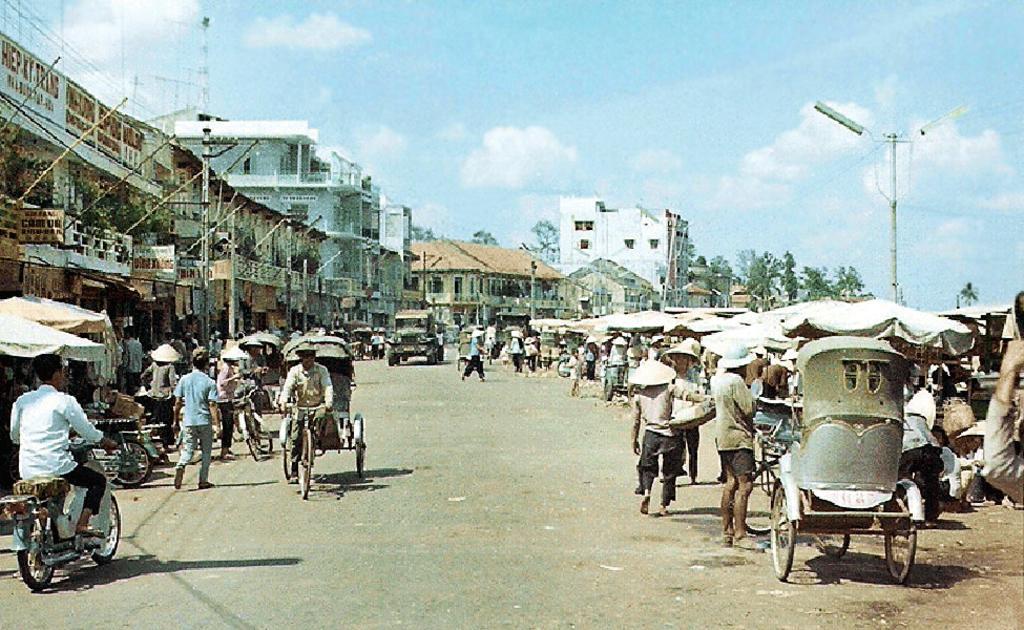In one or two sentences, can you explain what this image depicts? This picture is clicked outside the city. In this picture, we see men are riding the rickshaws and we even see vehicles are moving on the road. On the left side, we see the bikes parked on the road. Beside that, we see white tents, street lights, poles and buildings. On the right side, we see people are standing under the tents. There are trees and buildings in the background. At the top of the picture, we see the sky and the clouds. 